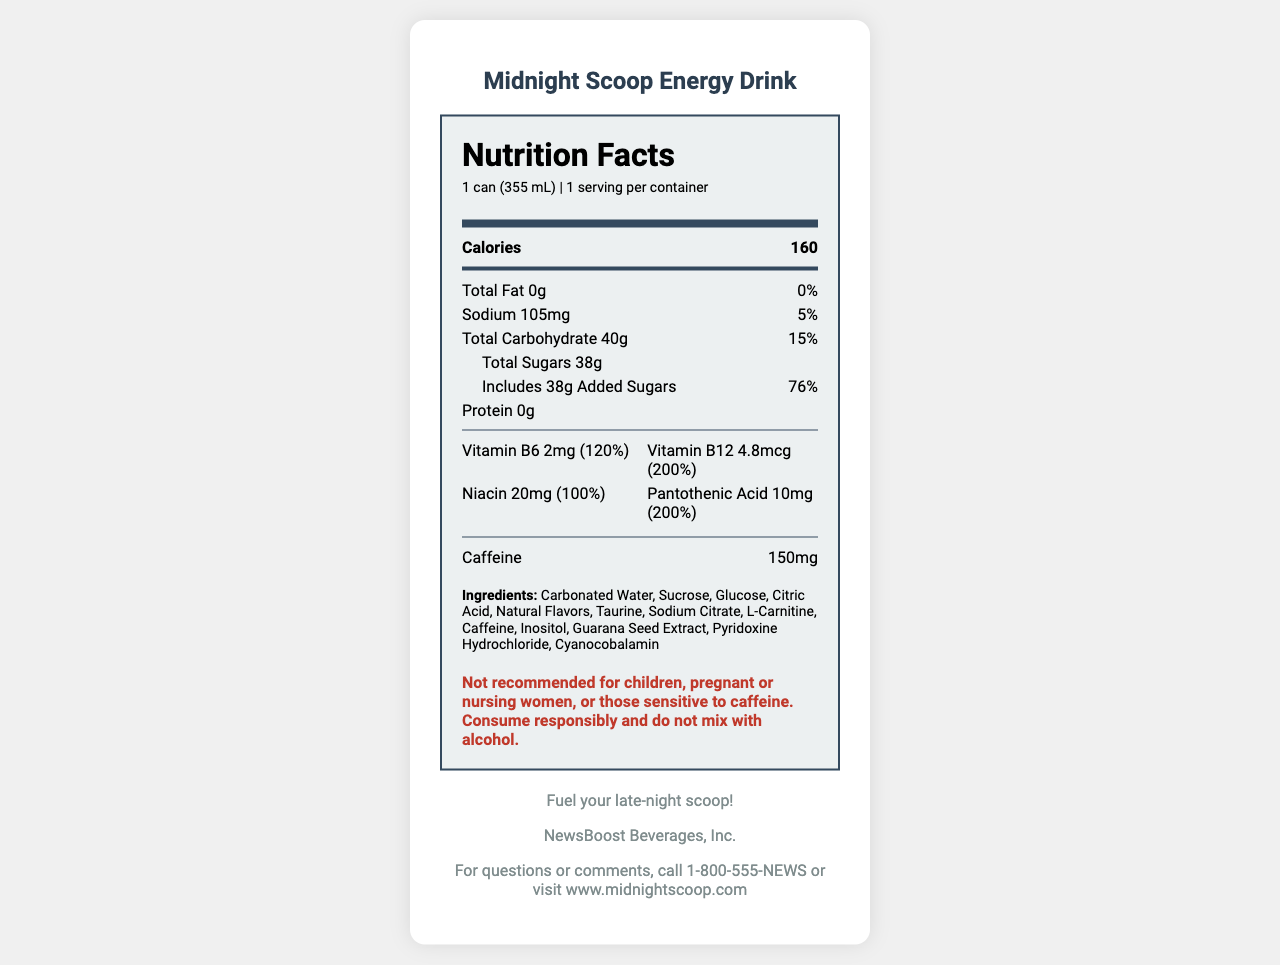what is the serving size of the Midnight Scoop Energy Drink? The serving size is listed as "1 can (355 mL)" under the serving information.
Answer: 1 can (355 mL) how many calories are in one serving of the Midnight Scoop Energy Drink? The calories per serving are listed as "160" in the nutrition facts section.
Answer: 160 what is the total carbohydrate content in one can? The total carbohydrate content is listed as "40g" in the nutrition facts section.
Answer: 40g how much added sugar does the drink contain? The total sugars section indicates that the drink contains "38g" of added sugars.
Answer: 38g what is the daily value percentage for sodium in this product? The nutrition facts state that the sodium daily value percentage is "5%".
Answer: 5% which vitamin is present the most in terms of daily value percentage? A. Vitamin B6 B. Vitamin B12 C. Niacin D. Pantothenic Acid Pantothenic Acid has the highest daily value percentage at "200%", as indicated in the vitamins section.
Answer: D how much caffeine is in one can of Midnight Scoop Energy Drink? The caffeine content is listed as "150mg" in the nutrition facts.
Answer: 150mg this product is safe for children and pregnant or nursing women. True or False? The warning section advises that this product is not recommended for children, pregnant or nursing women.
Answer: False how much protein is in the Midnight Scoop Energy Drink? The amount of protein is listed as "0g" in the nutrition facts.
Answer: 0g what percentage of daily value does the drink's niacin content satisfy? The nutrition facts list the niacin amount as "20mg," which satisfies "100%" of the daily value.
Answer: 100% which ingredient is listed first in the ingredients section? The first ingredient listed is "Carbonated Water."
Answer: Carbonated Water how many servings are there per container? The serving information states that there is "1 serving per container."
Answer: 1 describe the main idea of the document The document is structured to offer detailed nutritional information, serving size, main ingredients, and a warning for specific consumer groups, making it easy to understand the dietary impact of the product.
Answer: The document provides comprehensive nutrition facts and ingredient information for the Midnight Scoop Energy Drink, including serving size, calories, vitamins, caffeine content, and a warning for specific groups. what is the phone number for questions or comments about the product? The contact information section provides the phone number "1-800-555-NEWS."
Answer: 1-800-555-NEWS what is the brand slogan of the Midnight Scoop Energy Drink? The brand slogan, listed under brand info, is "Fuel your late-night scoop!"
Answer: "Fuel your late-night scoop!" does this product contain any allergens? The document only states that it is produced in a facility that processes soy and milk products but does not confirm the presence of allergens in the product itself.
Answer: Cannot be determined what is the total fat content in one can? The total fat content is listed as "0g" in the nutrition facts.
Answer: 0g what company manufactures the Midnight Scoop Energy Drink? This information is listed under the brand info section.
Answer: NewsBoost Beverages, Inc. how many vitamins and minerals are specified in the document? The document lists four vitamins and minerals: Vitamin B6, Vitamin B12, Niacin, and Pantothenic Acid.
Answer: 4 